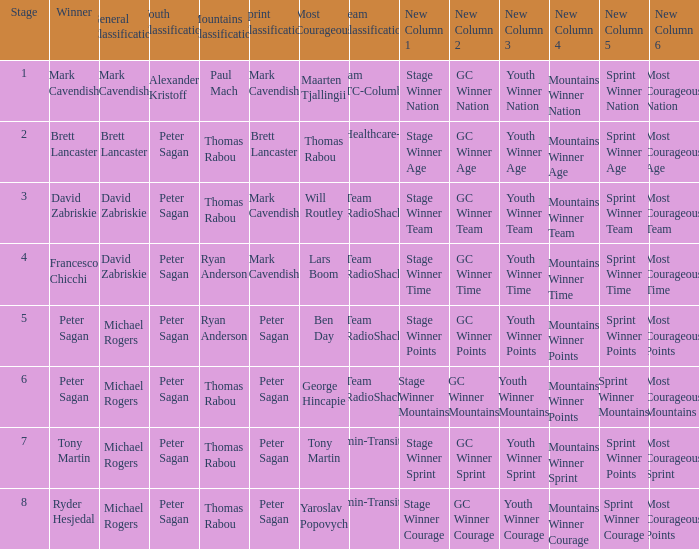When Ryan Anderson won the mountains classification, and Michael Rogers won the general classification, who won the sprint classification? Peter Sagan. 